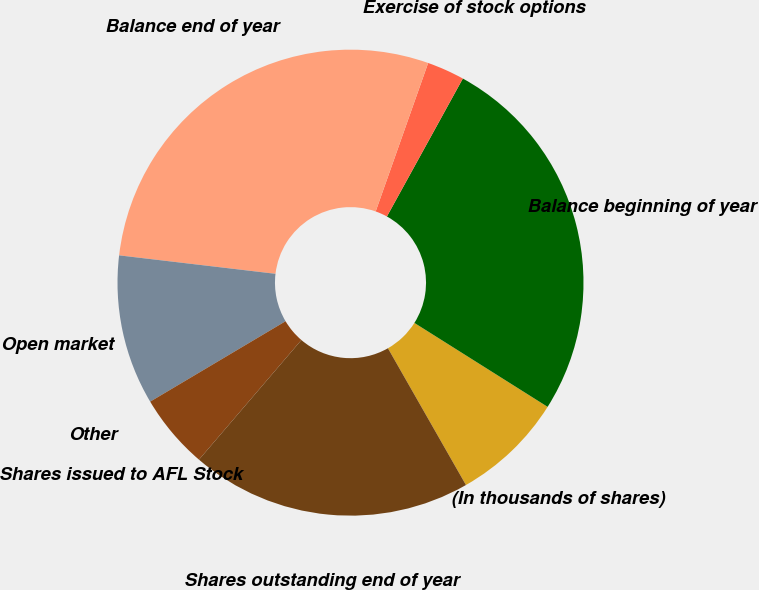<chart> <loc_0><loc_0><loc_500><loc_500><pie_chart><fcel>(In thousands of shares)<fcel>Balance beginning of year<fcel>Exercise of stock options<fcel>Balance end of year<fcel>Open market<fcel>Other<fcel>Shares issued to AFL Stock<fcel>Shares outstanding end of year<nl><fcel>7.8%<fcel>25.94%<fcel>2.6%<fcel>28.54%<fcel>10.4%<fcel>0.0%<fcel>5.2%<fcel>19.52%<nl></chart> 